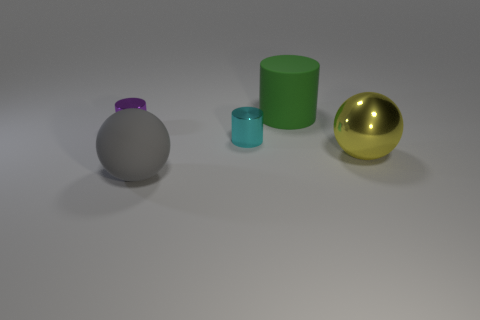Add 3 shiny spheres. How many objects exist? 8 Subtract all balls. How many objects are left? 3 Subtract all large cyan matte balls. Subtract all large green matte things. How many objects are left? 4 Add 2 rubber things. How many rubber things are left? 4 Add 2 small shiny cylinders. How many small shiny cylinders exist? 4 Subtract 0 red blocks. How many objects are left? 5 